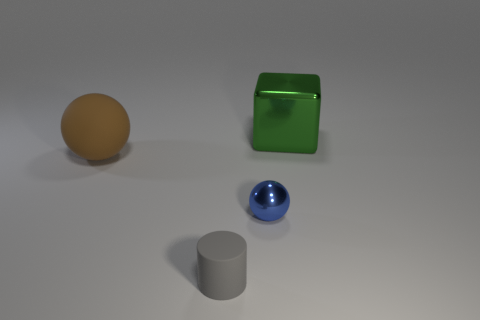Add 1 large green things. How many objects exist? 5 Subtract all cubes. How many objects are left? 3 Add 1 large matte objects. How many large matte objects are left? 2 Add 2 tiny matte cylinders. How many tiny matte cylinders exist? 3 Subtract 0 yellow cubes. How many objects are left? 4 Subtract all gray matte things. Subtract all large spheres. How many objects are left? 2 